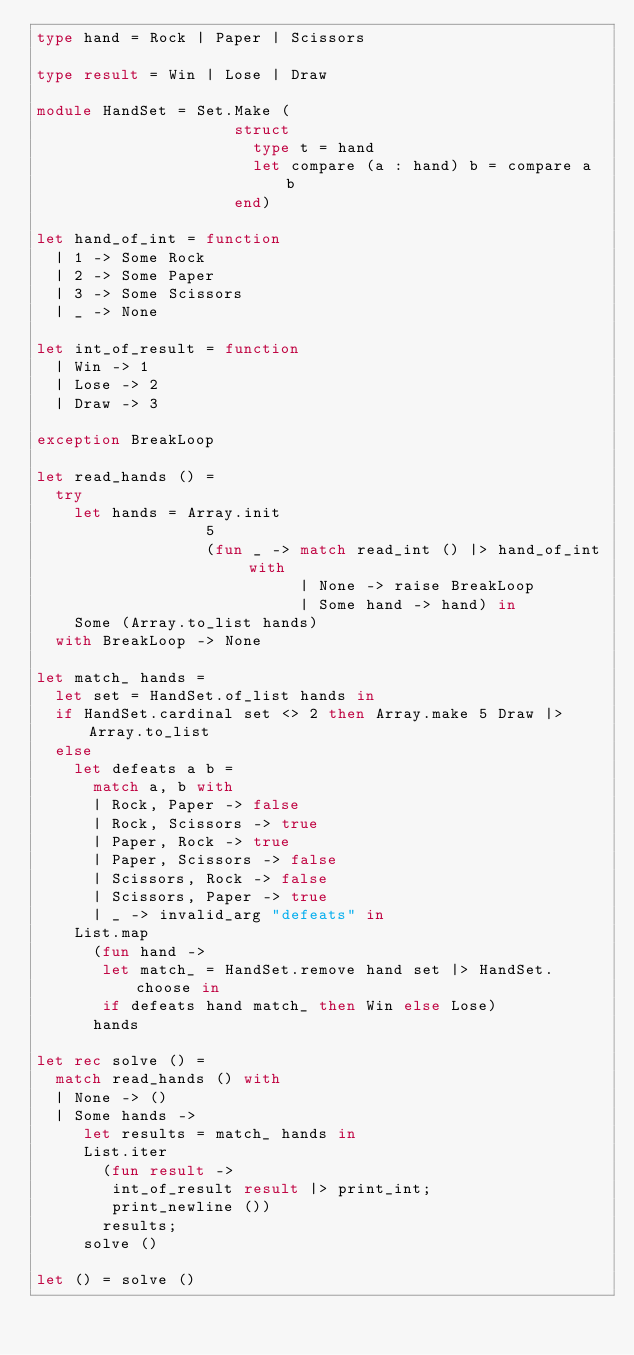Convert code to text. <code><loc_0><loc_0><loc_500><loc_500><_OCaml_>type hand = Rock | Paper | Scissors

type result = Win | Lose | Draw

module HandSet = Set.Make (
                     struct
                       type t = hand
                       let compare (a : hand) b = compare a b
                     end)

let hand_of_int = function
  | 1 -> Some Rock
  | 2 -> Some Paper
  | 3 -> Some Scissors
  | _ -> None

let int_of_result = function
  | Win -> 1
  | Lose -> 2
  | Draw -> 3

exception BreakLoop

let read_hands () =
  try
    let hands = Array.init
                  5
                  (fun _ -> match read_int () |> hand_of_int with
                            | None -> raise BreakLoop
                            | Some hand -> hand) in
    Some (Array.to_list hands)
  with BreakLoop -> None

let match_ hands =
  let set = HandSet.of_list hands in
  if HandSet.cardinal set <> 2 then Array.make 5 Draw |> Array.to_list
  else
    let defeats a b =
      match a, b with
      | Rock, Paper -> false
      | Rock, Scissors -> true
      | Paper, Rock -> true
      | Paper, Scissors -> false
      | Scissors, Rock -> false
      | Scissors, Paper -> true
      | _ -> invalid_arg "defeats" in
    List.map
      (fun hand ->
       let match_ = HandSet.remove hand set |> HandSet.choose in
       if defeats hand match_ then Win else Lose)
      hands

let rec solve () =
  match read_hands () with
  | None -> ()
  | Some hands ->
     let results = match_ hands in
     List.iter
       (fun result ->
        int_of_result result |> print_int;
        print_newline ())
       results;
     solve ()

let () = solve ()</code> 